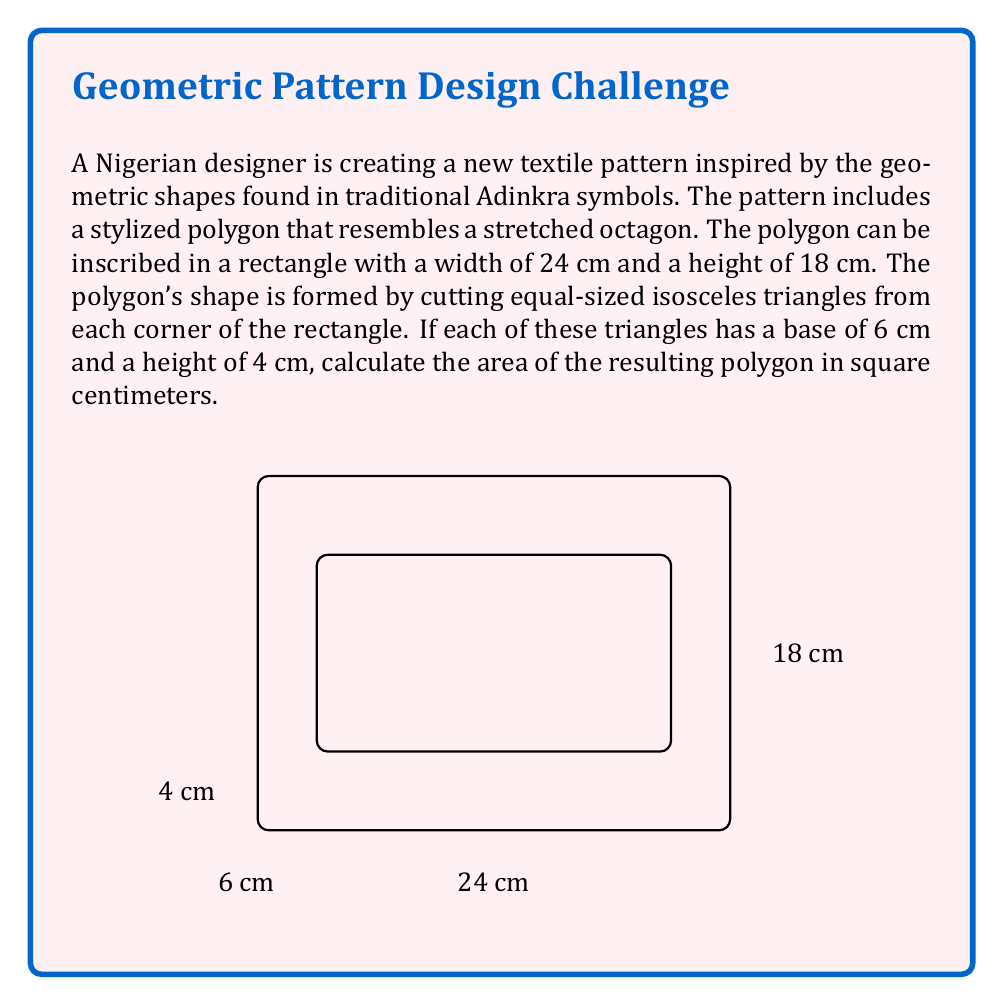Can you solve this math problem? To solve this problem, we'll follow these steps:

1) First, calculate the area of the rectangle:
   $$A_{rectangle} = 24 \text{ cm} \times 18 \text{ cm} = 432 \text{ cm}^2$$

2) Next, calculate the area of one isosceles triangle:
   $$A_{triangle} = \frac{1}{2} \times 6 \text{ cm} \times 4 \text{ cm} = 12 \text{ cm}^2$$

3) There are four such triangles (one at each corner), so the total area of the triangles is:
   $$A_{total triangles} = 4 \times 12 \text{ cm}^2 = 48 \text{ cm}^2$$

4) The area of the polygon is the difference between the rectangle's area and the total area of the triangles:
   $$A_{polygon} = A_{rectangle} - A_{total triangles}$$
   $$A_{polygon} = 432 \text{ cm}^2 - 48 \text{ cm}^2 = 384 \text{ cm}^2$$

Therefore, the area of the polygon inspired by the Adinkra symbol is 384 square centimeters.
Answer: 384 cm² 